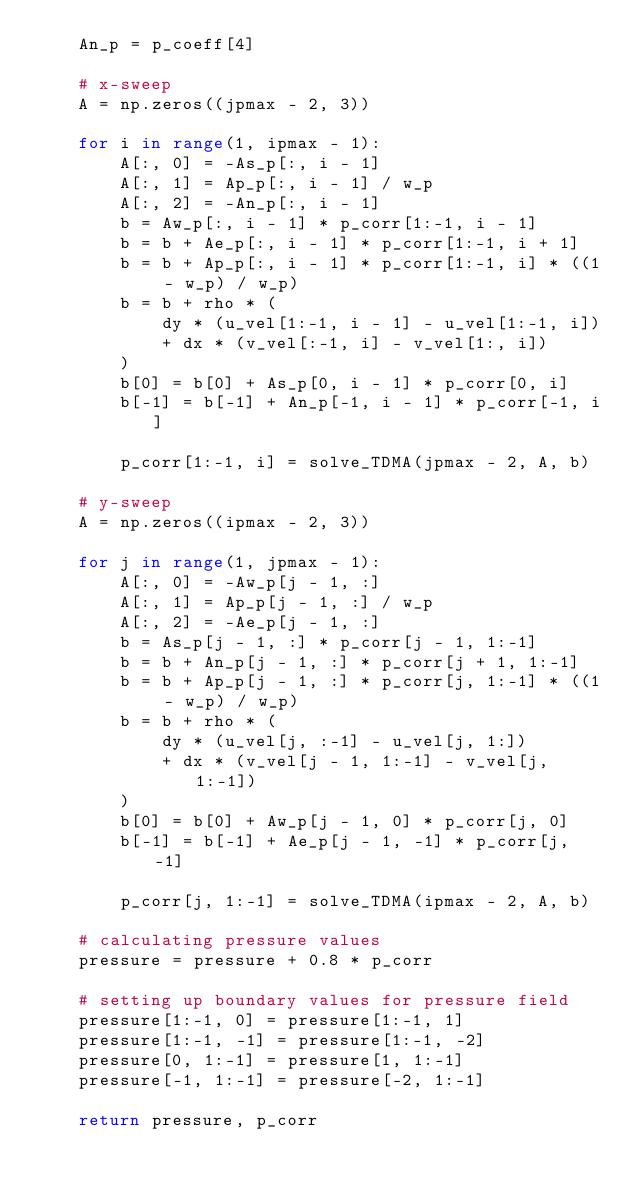<code> <loc_0><loc_0><loc_500><loc_500><_Python_>    An_p = p_coeff[4]

    # x-sweep
    A = np.zeros((jpmax - 2, 3))

    for i in range(1, ipmax - 1):
        A[:, 0] = -As_p[:, i - 1]
        A[:, 1] = Ap_p[:, i - 1] / w_p
        A[:, 2] = -An_p[:, i - 1]
        b = Aw_p[:, i - 1] * p_corr[1:-1, i - 1]
        b = b + Ae_p[:, i - 1] * p_corr[1:-1, i + 1]
        b = b + Ap_p[:, i - 1] * p_corr[1:-1, i] * ((1 - w_p) / w_p)
        b = b + rho * (
            dy * (u_vel[1:-1, i - 1] - u_vel[1:-1, i])
            + dx * (v_vel[:-1, i] - v_vel[1:, i])
        )
        b[0] = b[0] + As_p[0, i - 1] * p_corr[0, i]
        b[-1] = b[-1] + An_p[-1, i - 1] * p_corr[-1, i]

        p_corr[1:-1, i] = solve_TDMA(jpmax - 2, A, b)

    # y-sweep
    A = np.zeros((ipmax - 2, 3))

    for j in range(1, jpmax - 1):
        A[:, 0] = -Aw_p[j - 1, :]
        A[:, 1] = Ap_p[j - 1, :] / w_p
        A[:, 2] = -Ae_p[j - 1, :]
        b = As_p[j - 1, :] * p_corr[j - 1, 1:-1]
        b = b + An_p[j - 1, :] * p_corr[j + 1, 1:-1]
        b = b + Ap_p[j - 1, :] * p_corr[j, 1:-1] * ((1 - w_p) / w_p)
        b = b + rho * (
            dy * (u_vel[j, :-1] - u_vel[j, 1:])
            + dx * (v_vel[j - 1, 1:-1] - v_vel[j, 1:-1])
        )
        b[0] = b[0] + Aw_p[j - 1, 0] * p_corr[j, 0]
        b[-1] = b[-1] + Ae_p[j - 1, -1] * p_corr[j, -1]

        p_corr[j, 1:-1] = solve_TDMA(ipmax - 2, A, b)

    # calculating pressure values
    pressure = pressure + 0.8 * p_corr

    # setting up boundary values for pressure field
    pressure[1:-1, 0] = pressure[1:-1, 1]
    pressure[1:-1, -1] = pressure[1:-1, -2]
    pressure[0, 1:-1] = pressure[1, 1:-1]
    pressure[-1, 1:-1] = pressure[-2, 1:-1]

    return pressure, p_corr
</code> 